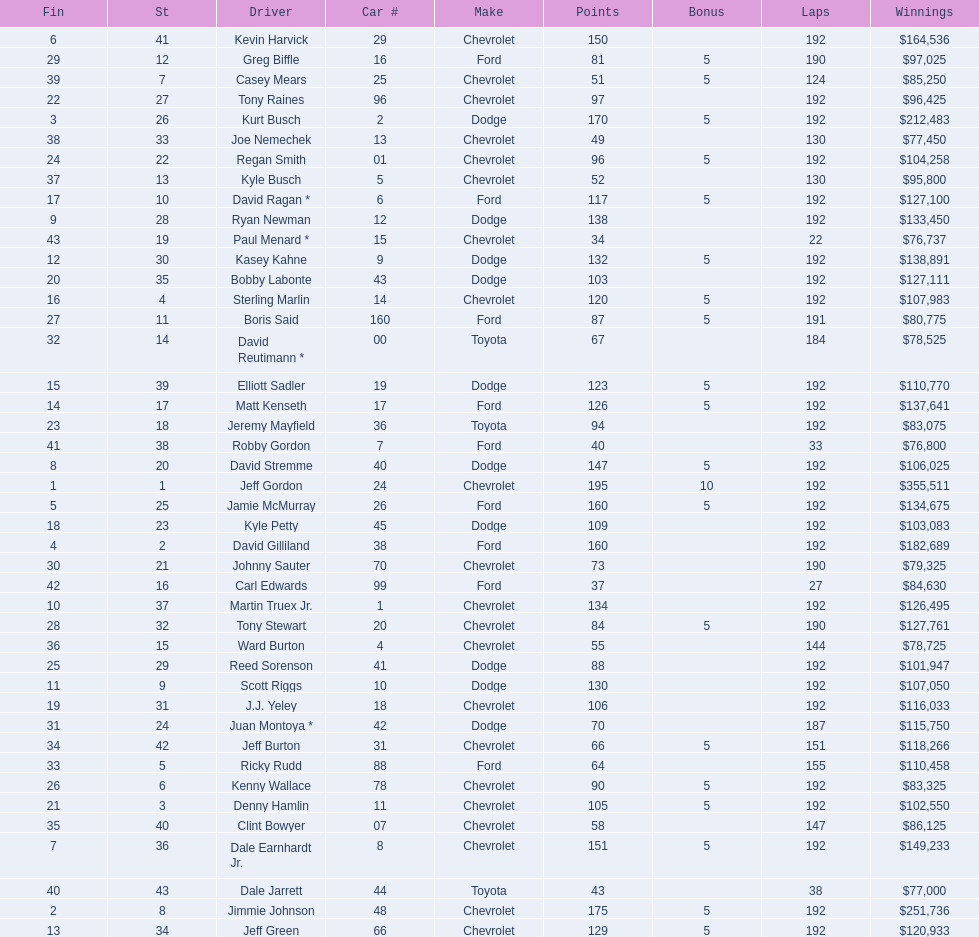What driver earned the least amount of winnings? Paul Menard *. 